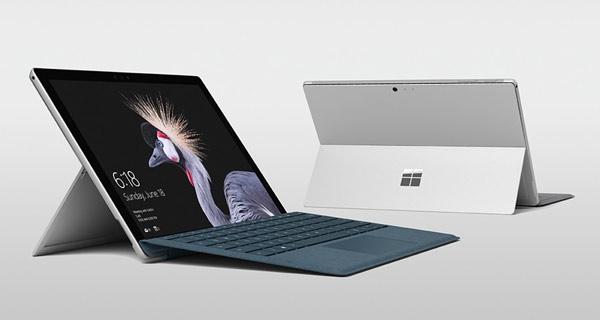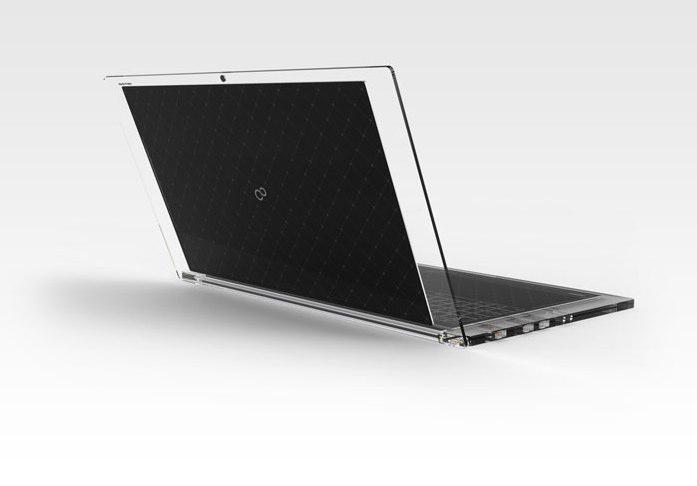The first image is the image on the left, the second image is the image on the right. Analyze the images presented: Is the assertion "In at least one image there is a silver bottomed laptop with a detachable mouse to the right." valid? Answer yes or no. No. The first image is the image on the left, the second image is the image on the right. Examine the images to the left and right. Is the description "One image shows an open laptop with its keyboard base attached and sitting flat, and the other image includes at least one screen propped up like an easel with a keyboard in front of it that does not appear to be attached." accurate? Answer yes or no. Yes. 